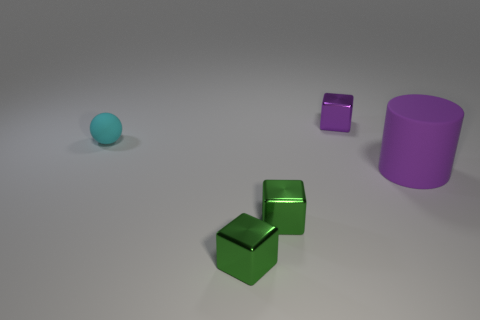Subtract all small green shiny blocks. How many blocks are left? 1 Subtract all purple cubes. How many cubes are left? 2 Subtract 1 blocks. How many blocks are left? 2 Add 3 purple cylinders. How many objects exist? 8 Subtract all cubes. How many objects are left? 2 Subtract all small purple shiny blocks. Subtract all purple metal things. How many objects are left? 3 Add 1 purple cubes. How many purple cubes are left? 2 Add 2 gray matte blocks. How many gray matte blocks exist? 2 Subtract 1 purple cubes. How many objects are left? 4 Subtract all brown cubes. Subtract all yellow cylinders. How many cubes are left? 3 